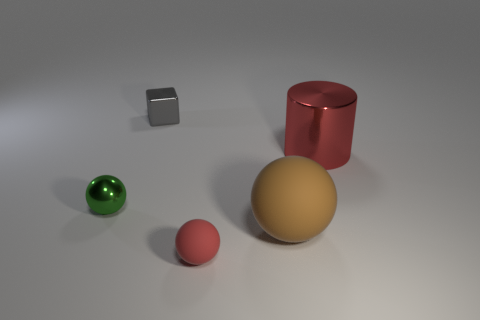Add 2 small cubes. How many objects exist? 7 Subtract all cylinders. How many objects are left? 4 Add 3 red things. How many red things exist? 5 Subtract 0 green cubes. How many objects are left? 5 Subtract all red shiny cylinders. Subtract all metallic cylinders. How many objects are left? 3 Add 2 tiny matte things. How many tiny matte things are left? 3 